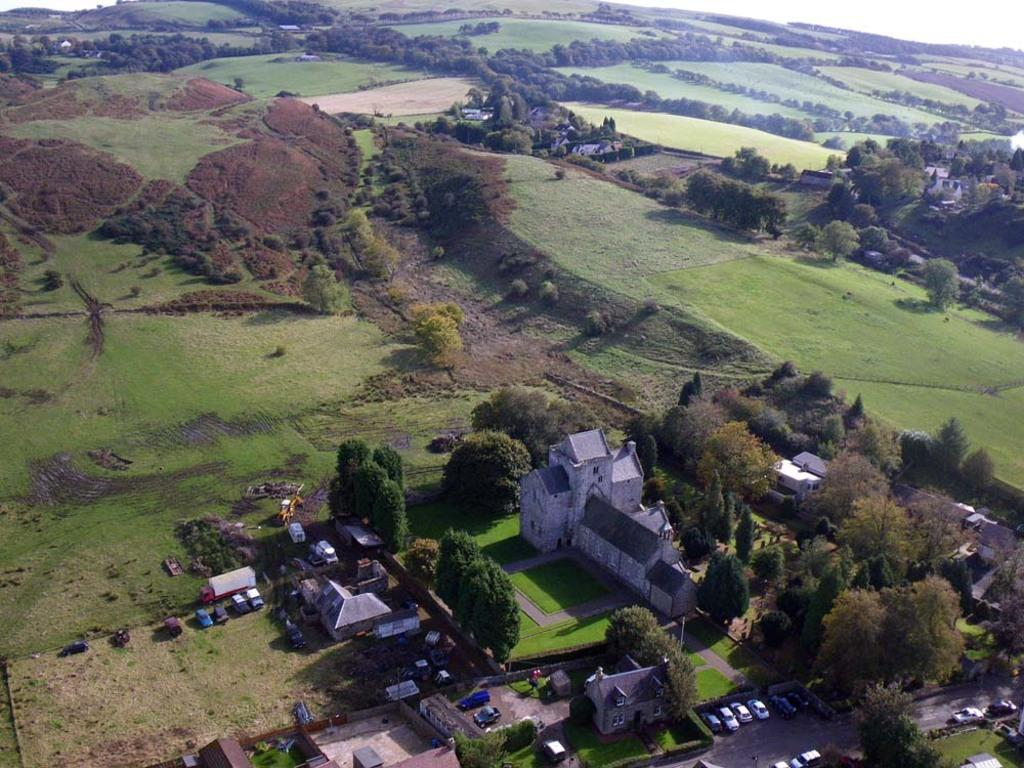What type of structures can be seen in the image? There are houses in the image. What type of vegetation is present in the image? There are trees and grass in the image. What else can be seen in the image besides houses and vegetation? There are vehicles in the image. What is the position of the waste in the image? There is no waste present in the image, so it is not possible to determine its position. 